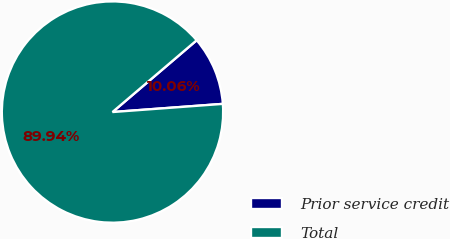<chart> <loc_0><loc_0><loc_500><loc_500><pie_chart><fcel>Prior service credit<fcel>Total<nl><fcel>10.06%<fcel>89.94%<nl></chart> 